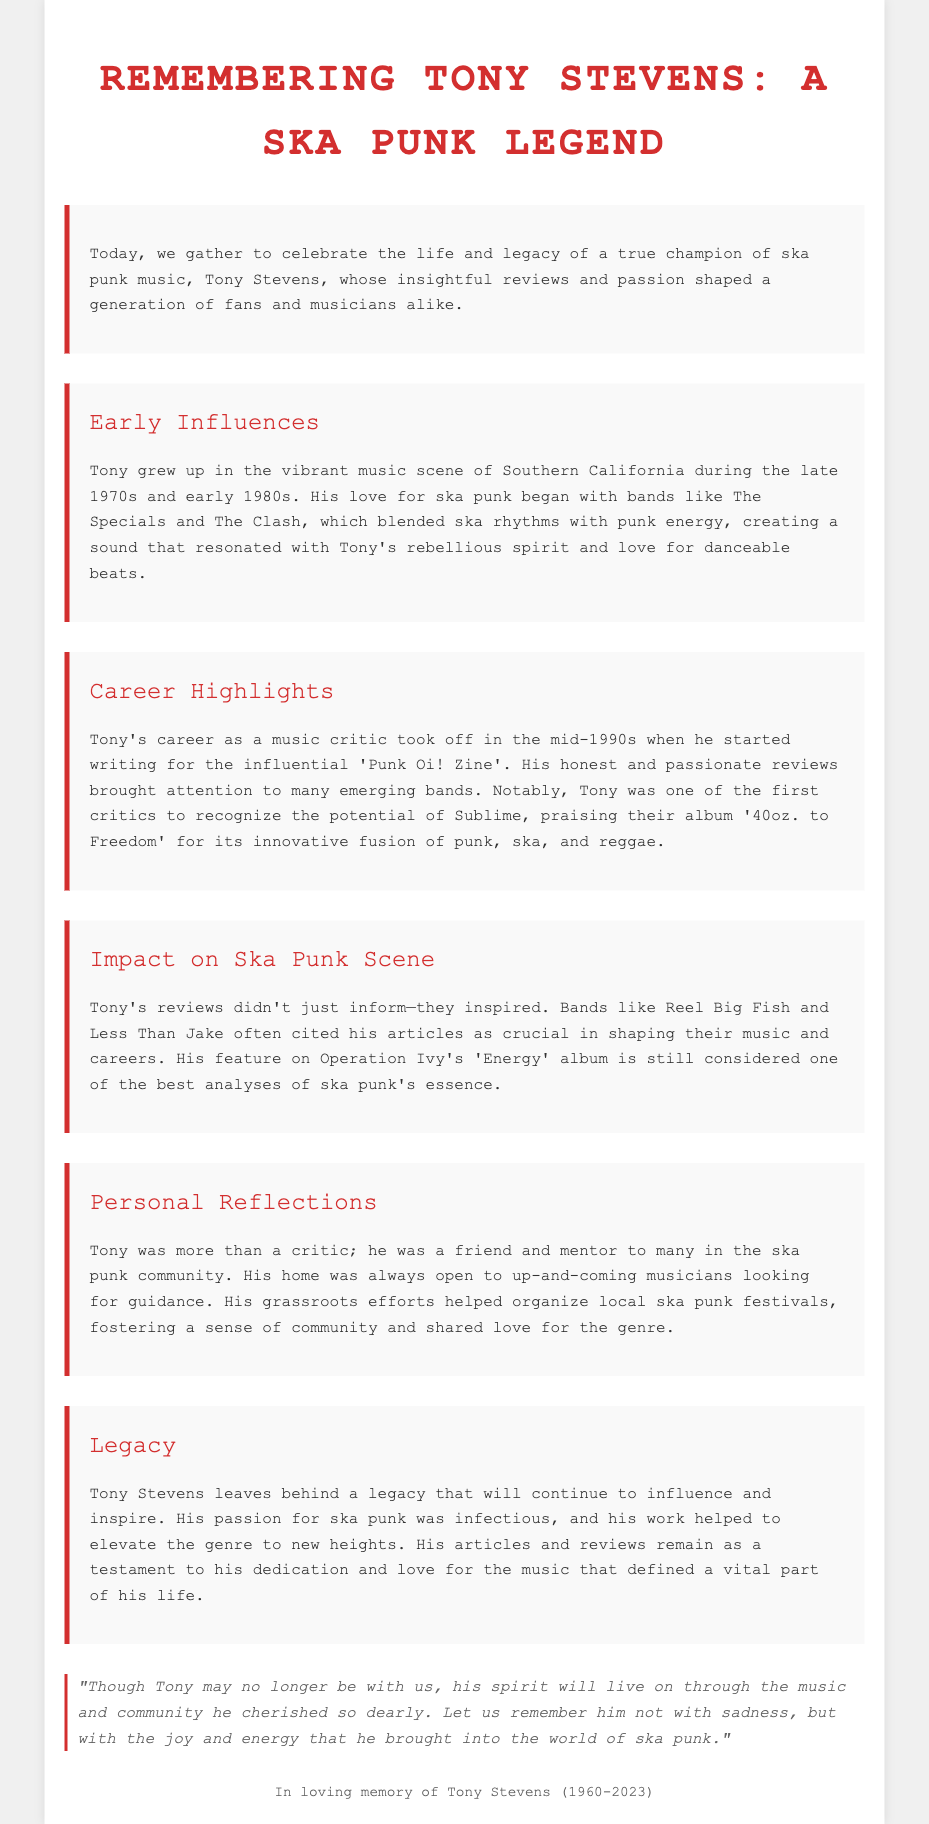What was Tony's birth year? The document states that Tony Stevens was born in 1960.
Answer: 1960 What influential zine did Tony write for? According to the document, Tony began writing for 'Punk Oi! Zine'.
Answer: Punk Oi! Zine Which album did Tony praise for its fusion of punk, ska, and reggae? The document notes that Tony praised Sublime's '40oz. to Freedom' for its innovative fusion.
Answer: 40oz. to Freedom What ska punk bands cited Tony's articles as influential? The document mentions that bands like Reel Big Fish and Less Than Jake cited his articles as crucial.
Answer: Reel Big Fish and Less Than Jake What is considered one of Tony's best analyses of ska punk? The document states that his feature on Operation Ivy's 'Energy' album is still regarded as one of the best analyses.
Answer: Energy What was one of Tony's contributions to the ska punk community? The document highlights that he helped organize local ska punk festivals.
Answer: Local ska punk festivals What significant impact did Tony's reviews have? The document outlines that Tony's reviews inspired many emerging bands in the ska punk scene.
Answer: Inspired emerging bands What type of gatherings did Tony's home host for musicians? According to the document, his home was always open to up-and-coming musicians looking for guidance.
Answer: Guidance gatherings What does the eulogy emphasize about Tony's legacy? The document asserts that his legacy will continue to influence and inspire the ska punk genre.
Answer: Influence and inspire 